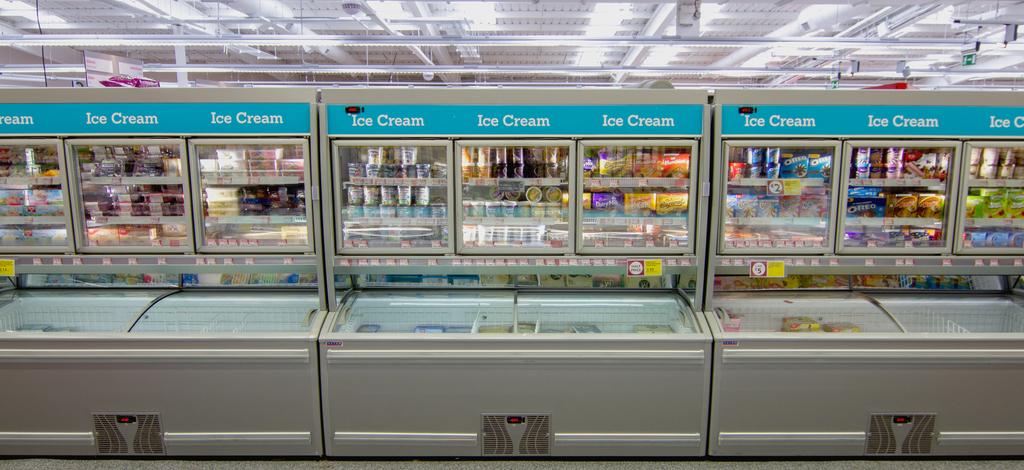Is this a grocery store?
Your answer should be very brief. Yes. How many ice cream sections are there here?
Make the answer very short. 9. 